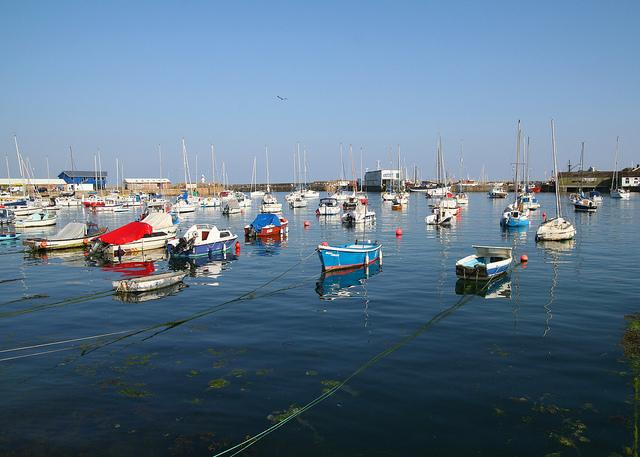These items that are moving can be referred to as being part of what? Please explain your reasoning. fleet. A group of ships is called a fleet. 